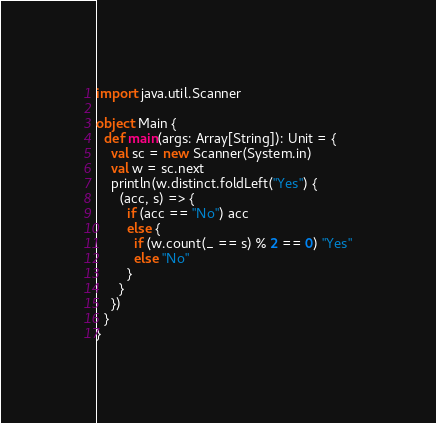Convert code to text. <code><loc_0><loc_0><loc_500><loc_500><_Scala_>import java.util.Scanner

object Main {
  def main(args: Array[String]): Unit = {
    val sc = new Scanner(System.in)
    val w = sc.next
    println(w.distinct.foldLeft("Yes") {
      (acc, s) => {
        if (acc == "No") acc
        else {
          if (w.count(_ == s) % 2 == 0) "Yes"
          else "No"
        }
      }
    })
  }
}
</code> 